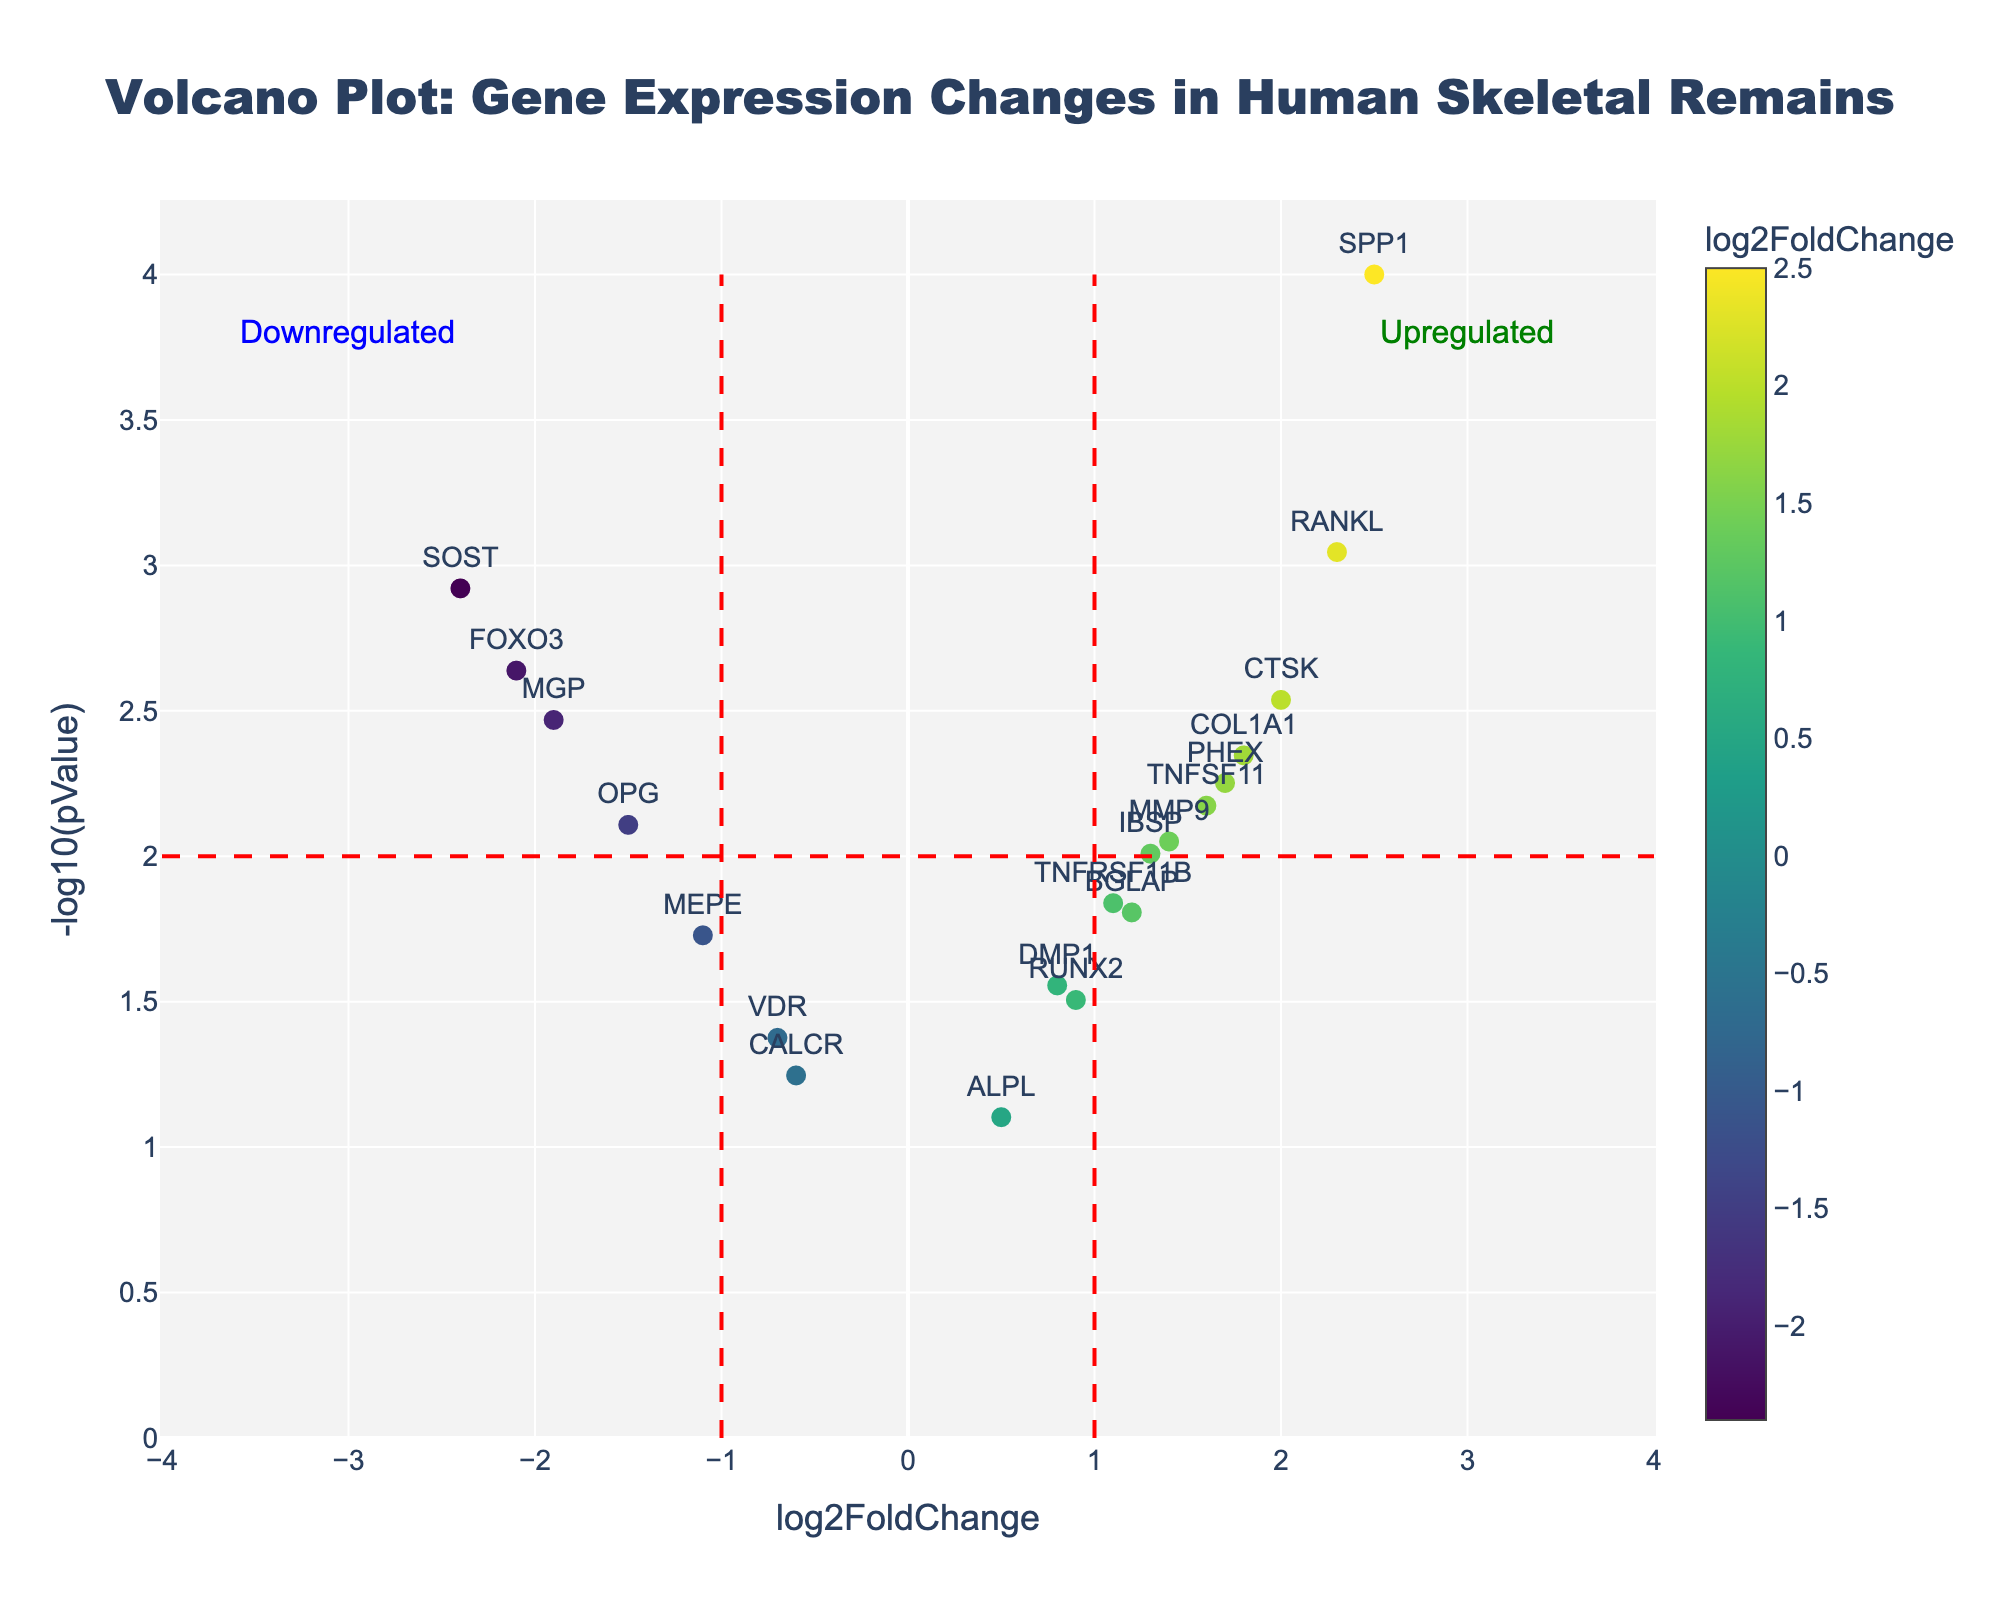What is the color scheme used in the volcano plot? The volcano plot uses a 'Viridis' color scheme. The color of each marker represents the log2FoldChange value of the corresponding gene, with warmer colors indicating higher values and cooler colors indicating lower values.
Answer: Viridis How many genes fall into the upregulated category based on the significance lines? Genes are categorized as upregulated if their log2FoldChange is greater than 1 and their -log10(pValue) is greater than 2. By looking at the markers that satisfy these criteria, we see four genes: RANKL, SPP1, CTSK, and COL1A1.
Answer: 4 Which gene has the highest log2FoldChange value, and what is it? The gene with the highest log2FoldChange value can be identified by looking at the horizontal axis. SPP1 has the highest log2FoldChange value of 2.5.
Answer: SPP1, 2.5 What does the -log10(pValue) represent in this plot? The -log10(pValue) is a transformed value of the p-value. Lower p-values (indicating higher statistical significance) correspond to higher -log10(pValue) values. This transformation is done to better visualize the significance of gene expression changes.
Answer: Transformed p-value Is there a gene that is downregulated with a log2FoldChange of less than -2? If so, which one? By looking at the horizontal axis to the left of the -2 mark, we find two genes: FOXO3 and SOST, which have log2FoldChange values of -2.1 and -2.4, respectively.
Answer: FOXO3 and SOST Which gene is closest to the threshold for upregulation? To find the gene closest to the threshold for upregulation, examine the marker nearest to the log2FoldChange value of 1 and a high -log10(pValue). The gene ALPL, with a log2FoldChange of 0.5, is closest but still below the threshold.
Answer: ALPL What trend do you observe between p-value and gene expression changes? Generally, genes with more extreme log2FoldChange values (either high positive or low negative) tend to have lower p-values, leading to higher -log10(pValue), reflecting greater statistical significance.
Answer: More extreme fold changes, more significant How does the plot distinguish between upregulated and downregulated genes? The plot uses red dashed lines at log2FoldChange values of 1 and -1 to visually separate upregulated (log2FoldChange > 1) from downregulated genes (log2FoldChange < -1). Annotations in green and blue further label these categories.
Answer: Red dashed lines and annotations Which gene has the lowest p-value and how does it compare in terms of log2FoldChange? The gene with the lowest p-value corresponds to the highest -log10(pValue). SPP1 has the lowest p-value (0.0001), with a log2FoldChange value of 2.5.
Answer: SPP1 